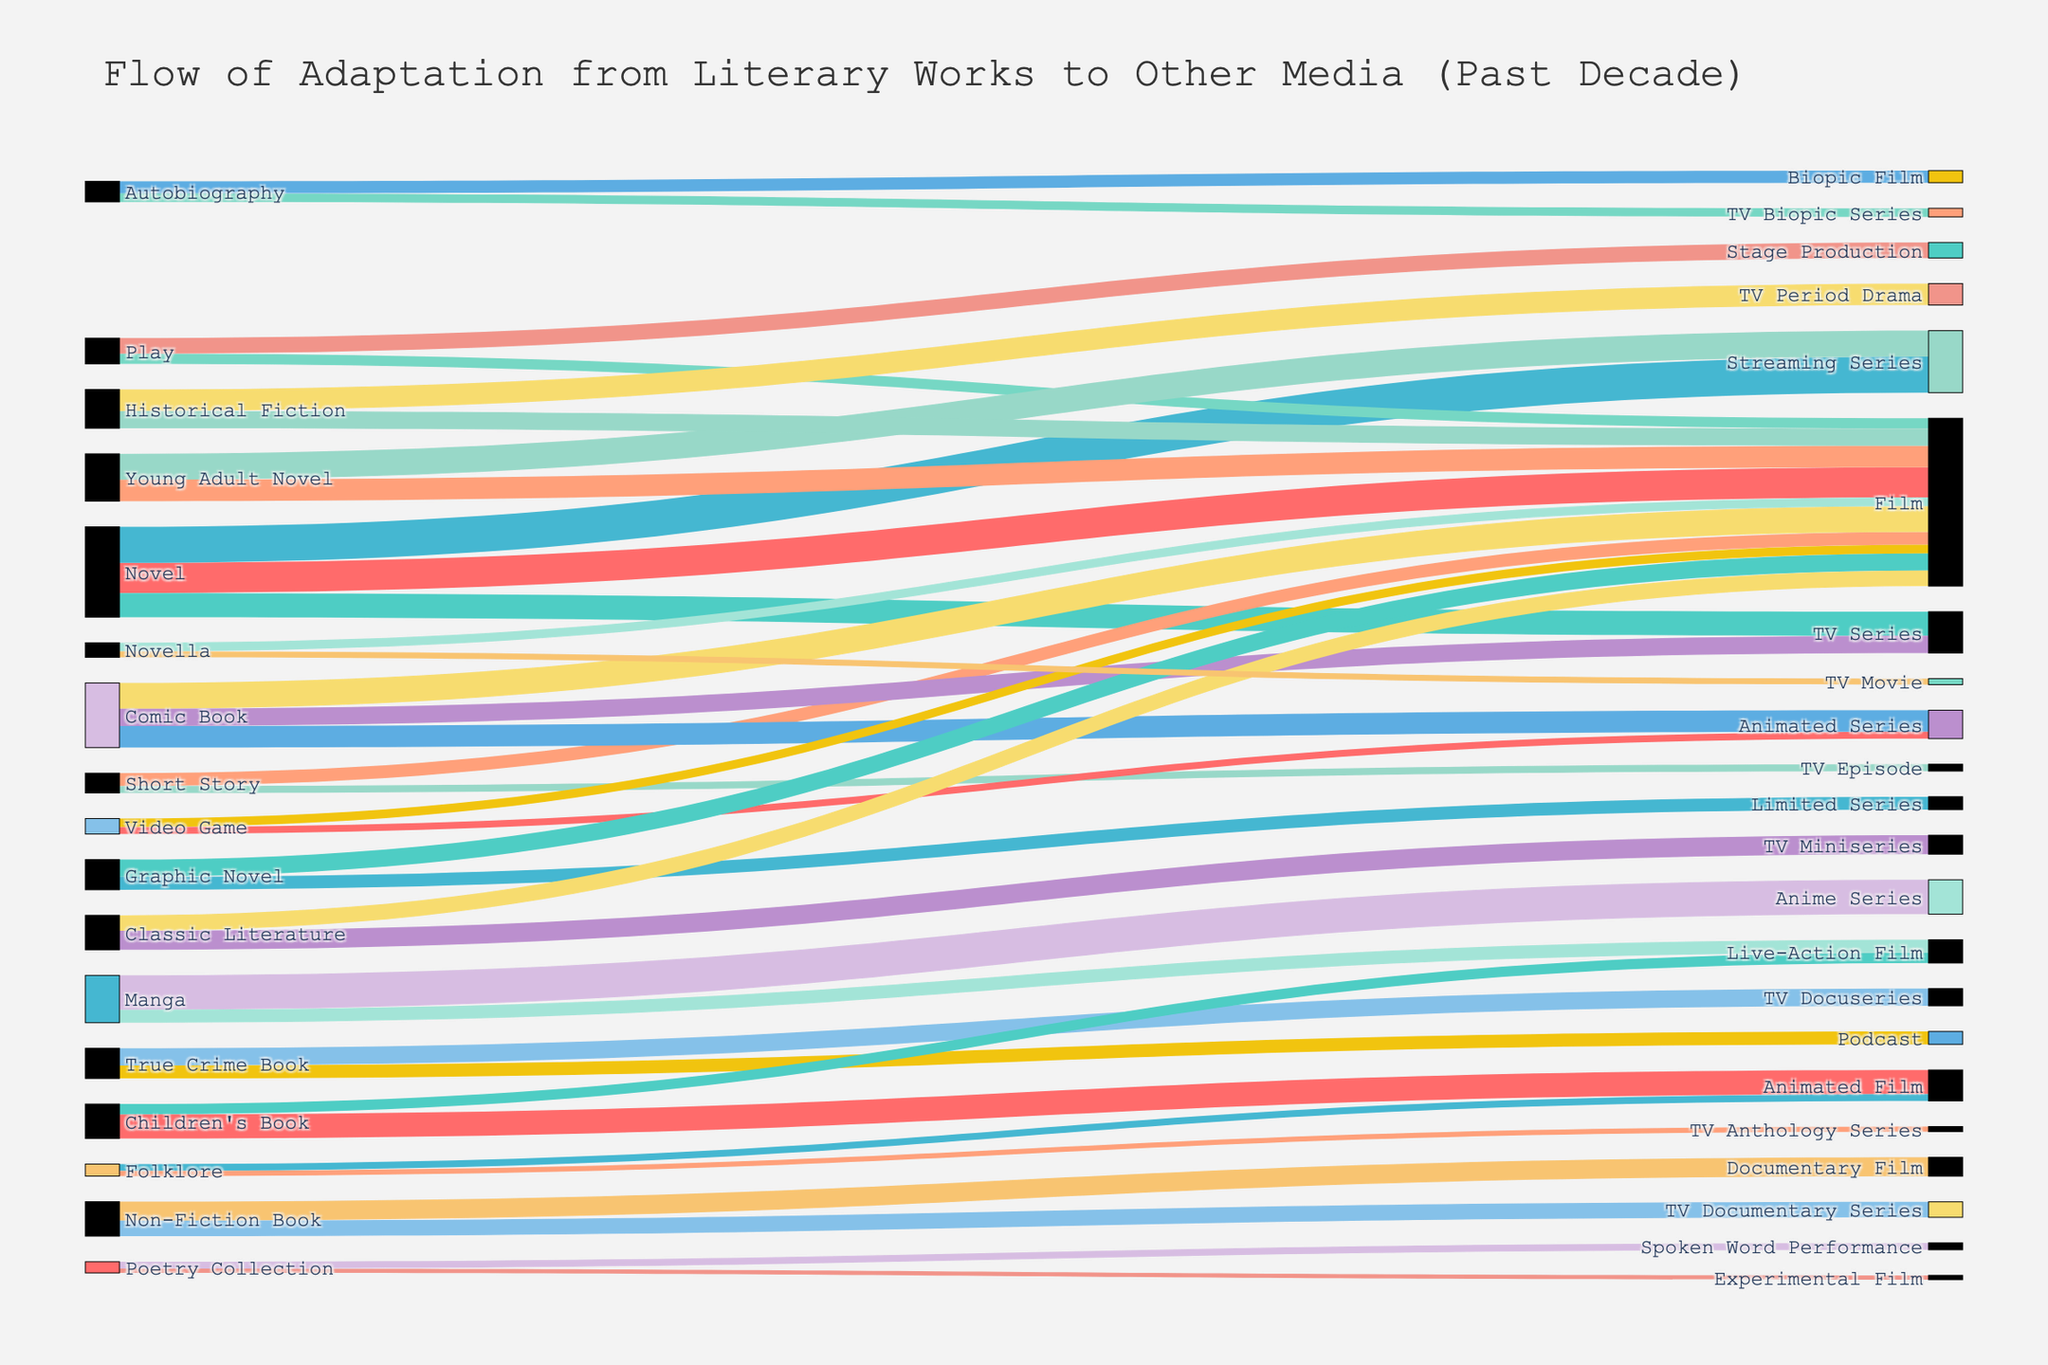What's the most frequently adapted type of literary work to film? By examining the connections flowing into "Film", we can see which source has the highest value. Novels are the most frequently adapted literary work to films with a value of 35.
Answer: Novels Which type of literary work is more commonly adapted into TV Series: Comic Books or Novels? Looking at the connections flowing into "TV Series", we see Novels (28) and Comic Books (20). Since 28 is greater than 20, Novels are more commonly adapted into TV Series than Comic Books.
Answer: Novels Which adaptation path has the highest value? By observing the figure, the adaptation path with the highest value is "Manga" to "Anime Series" with a value of 40.
Answer: Manga to Anime Series How many total adaptations are there from Manga? Adding up the values of adaptations from Manga to Anime Series (40) and Live-Action Film (15) yields a total of 55.
Answer: 55 Is the value of adaptations from Plays to Films higher than the value of adaptations from Plays to Stage Productions? Checking the visual, Plays to Films has a value of 12 while Plays to Stage Productions has a value of 18. 12 is less than 18, so no, the value is not higher.
Answer: No What is the average value of adaptations from Non-Fiction Books? The two adaptation pathways from Non-Fiction Books are to Documentary Films (22) and TV Documentary Series (18). Adding these gives 40, and dividing by 2 results in an average of 20.
Answer: 20 Which has more adaptations: True Crime Books to TV Docuseries or True Crime Books to Podcasts? From the figure, True Crime Books to TV Docuseries has a value of 20 and True Crime Books to Podcasts has a value of 15. Thus, True Crime Books to TV Docuseries has more adaptations.
Answer: TV Docuseries Between Children's Books and Folklore, which has more adaptations to Animated Films? Children's Books are adapted to Animated Films with a value of 28 whereas Folklore has a value of 8. Therefore, Children's Books have more adaptations in this category.
Answer: Children's Books What is the sum of all adaptations to Films from all types of literary works? Summing the values leading to Films: Novel (35), Short Story (15), Comic Book (30), Play (12), Manga (15), Video Game (10), Graphic Novel (20), Young Adult Novel (25), Classic Literature (18), Novella (10), Children's Book (12), Historical Fiction (20) gives a total of 222.
Answer: 222 